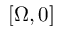Convert formula to latex. <formula><loc_0><loc_0><loc_500><loc_500>[ \Omega , 0 ]</formula> 